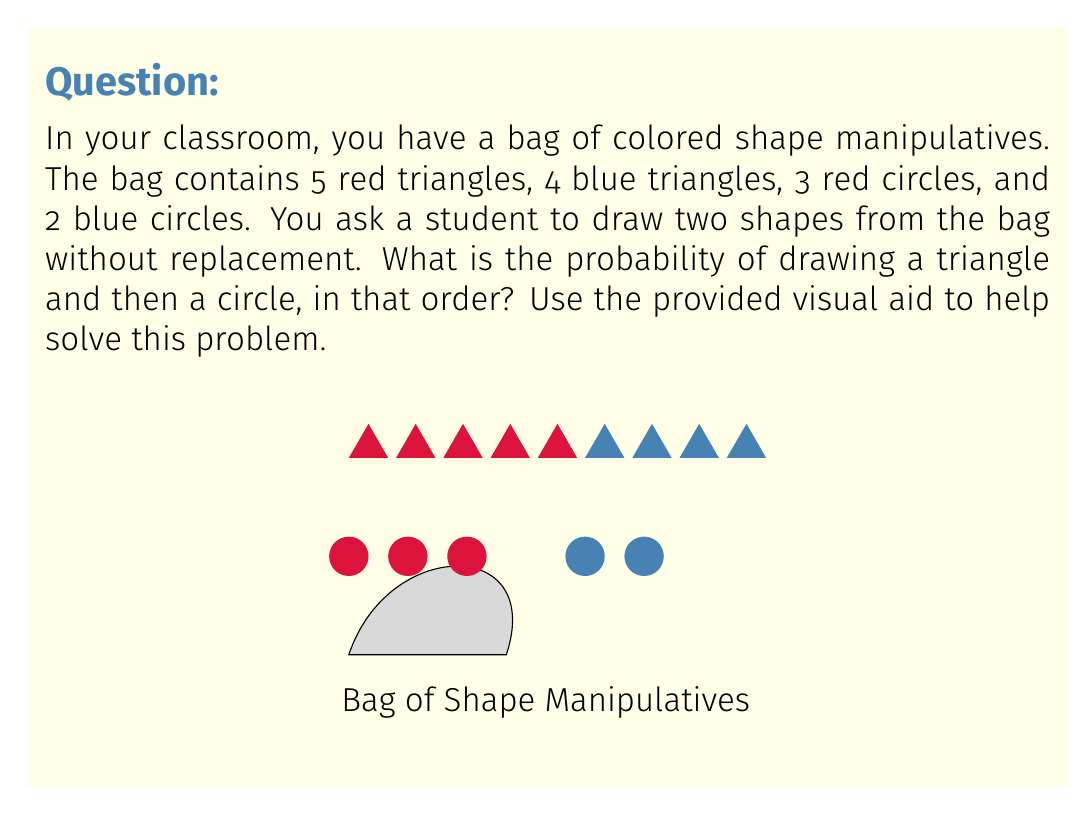Give your solution to this math problem. Let's approach this step-by-step using the visual aid:

1) First, we need to calculate the total number of shapes:
   5 + 4 + 3 + 2 = 14 shapes in total

2) For the first draw, we need to select a triangle. There are:
   5 red triangles + 4 blue triangles = 9 triangles

3) The probability of drawing a triangle on the first draw is:
   $P(\text{triangle}) = \frac{9}{14}$

4) After drawing a triangle, there are 13 shapes left, of which 5 are circles:
   3 red circles + 2 blue circles = 5 circles

5) The probability of drawing a circle on the second draw, given that we've already drawn a triangle, is:
   $P(\text{circle | triangle}) = \frac{5}{13}$

6) To find the probability of both events occurring in this order, we multiply these probabilities:

   $P(\text{triangle and then circle}) = P(\text{triangle}) \times P(\text{circle | triangle})$

   $= \frac{9}{14} \times \frac{5}{13} = \frac{45}{182} = \frac{45}{182} \approx 0.2473$

Therefore, the probability of drawing a triangle and then a circle is $\frac{45}{182}$ or approximately 24.73%.
Answer: $\frac{45}{182}$ 